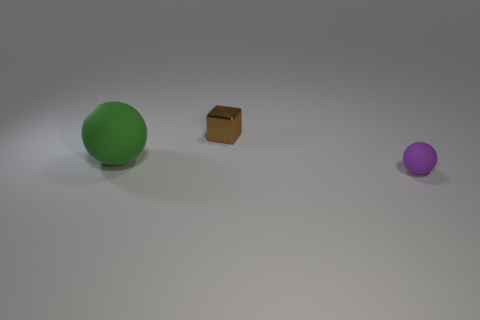Subtract 1 balls. How many balls are left? 1 Add 3 blue metallic cylinders. How many objects exist? 6 Subtract 0 cyan cylinders. How many objects are left? 3 Subtract all cubes. How many objects are left? 2 Subtract all large purple shiny balls. Subtract all rubber spheres. How many objects are left? 1 Add 1 green things. How many green things are left? 2 Add 1 tiny yellow spheres. How many tiny yellow spheres exist? 1 